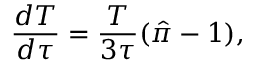Convert formula to latex. <formula><loc_0><loc_0><loc_500><loc_500>\frac { d T } { d \tau } = \frac { T } { 3 \tau } ( \hat { \pi } - 1 ) ,</formula> 